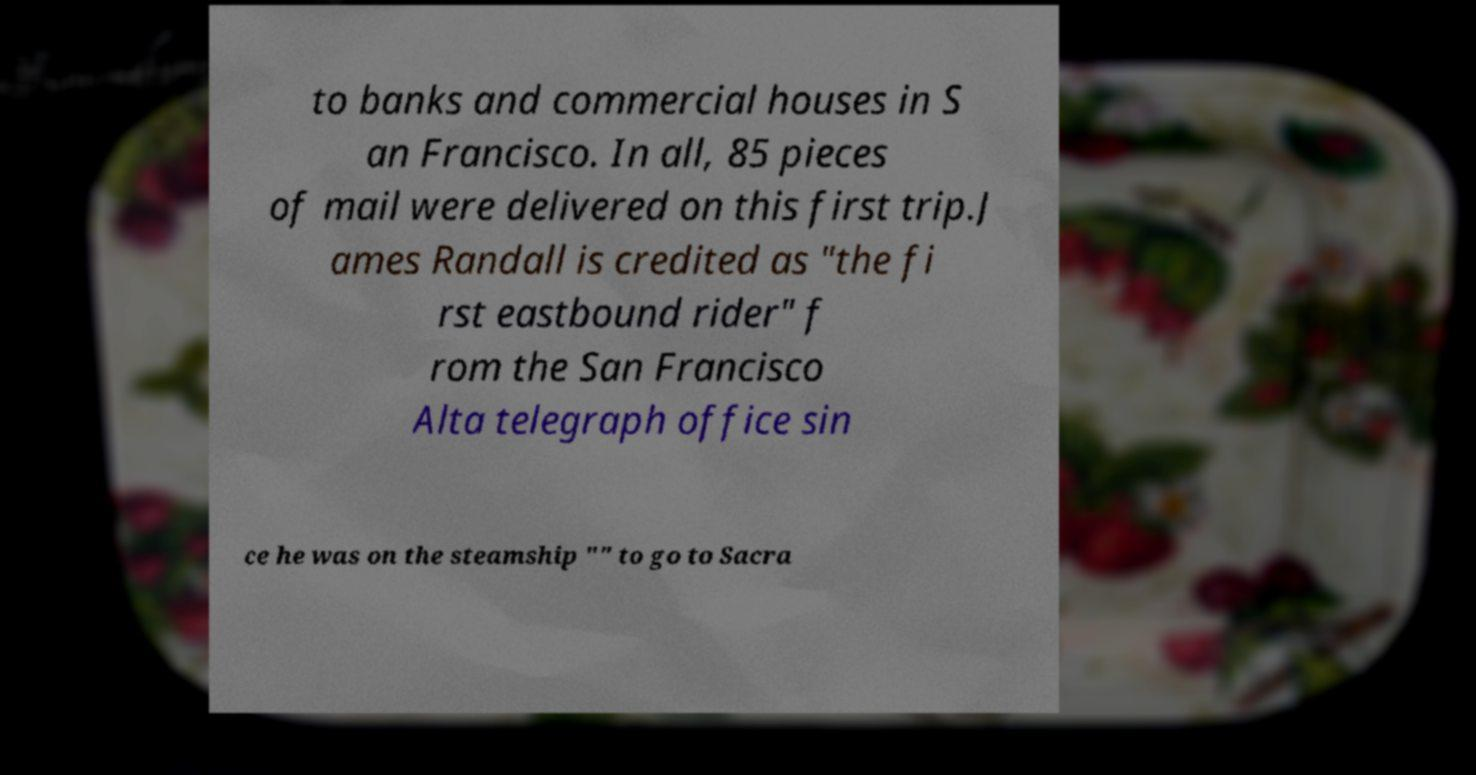Can you read and provide the text displayed in the image?This photo seems to have some interesting text. Can you extract and type it out for me? to banks and commercial houses in S an Francisco. In all, 85 pieces of mail were delivered on this first trip.J ames Randall is credited as "the fi rst eastbound rider" f rom the San Francisco Alta telegraph office sin ce he was on the steamship "" to go to Sacra 